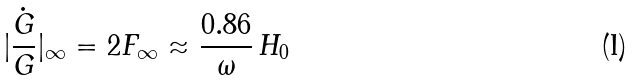Convert formula to latex. <formula><loc_0><loc_0><loc_500><loc_500>| \frac { \dot { G } } { G } | _ { \infty } = 2 F _ { \infty } \approx \frac { 0 . 8 6 } { \omega } \, H _ { 0 }</formula> 